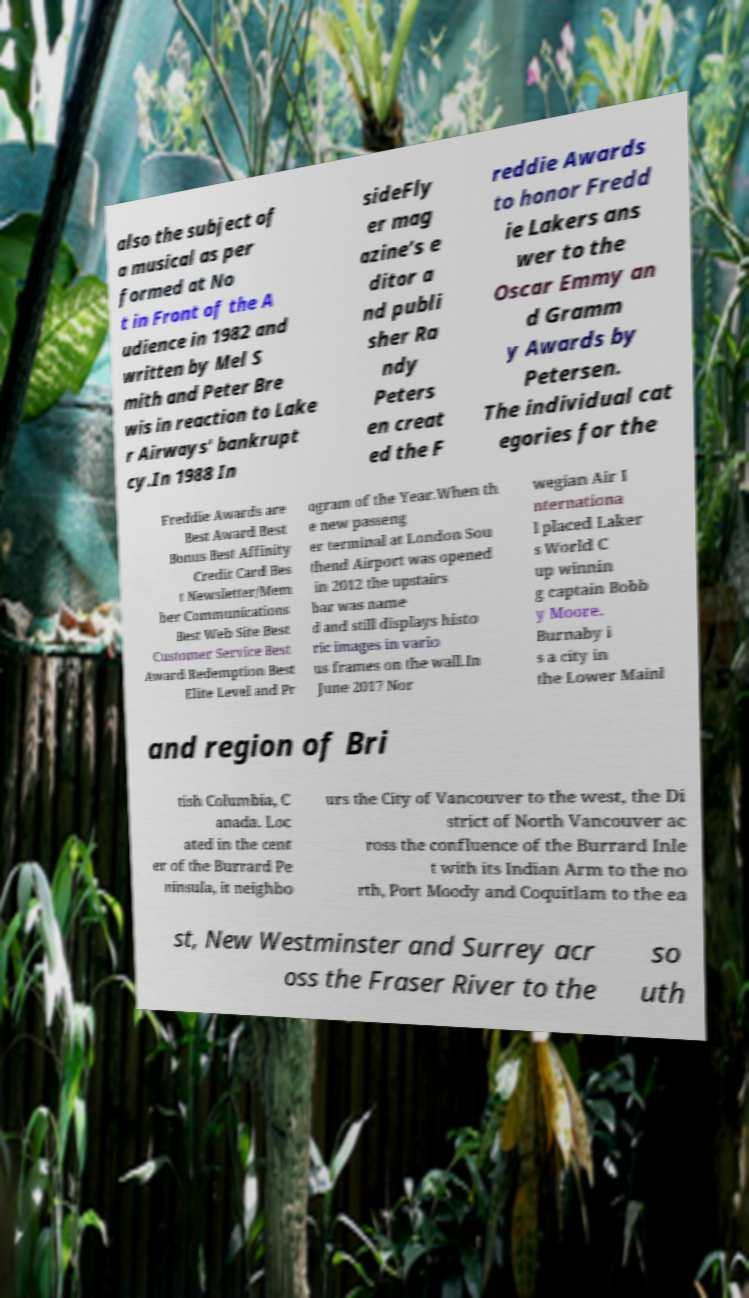Can you read and provide the text displayed in the image?This photo seems to have some interesting text. Can you extract and type it out for me? also the subject of a musical as per formed at No t in Front of the A udience in 1982 and written by Mel S mith and Peter Bre wis in reaction to Lake r Airways' bankrupt cy.In 1988 In sideFly er mag azine’s e ditor a nd publi sher Ra ndy Peters en creat ed the F reddie Awards to honor Fredd ie Lakers ans wer to the Oscar Emmy an d Gramm y Awards by Petersen. The individual cat egories for the Freddie Awards are Best Award Best Bonus Best Affinity Credit Card Bes t Newsletter/Mem ber Communications Best Web Site Best Customer Service Best Award Redemption Best Elite Level and Pr ogram of the Year.When th e new passeng er terminal at London Sou thend Airport was opened in 2012 the upstairs bar was name d and still displays histo ric images in vario us frames on the wall.In June 2017 Nor wegian Air I nternationa l placed Laker s World C up winnin g captain Bobb y Moore. Burnaby i s a city in the Lower Mainl and region of Bri tish Columbia, C anada. Loc ated in the cent er of the Burrard Pe ninsula, it neighbo urs the City of Vancouver to the west, the Di strict of North Vancouver ac ross the confluence of the Burrard Inle t with its Indian Arm to the no rth, Port Moody and Coquitlam to the ea st, New Westminster and Surrey acr oss the Fraser River to the so uth 